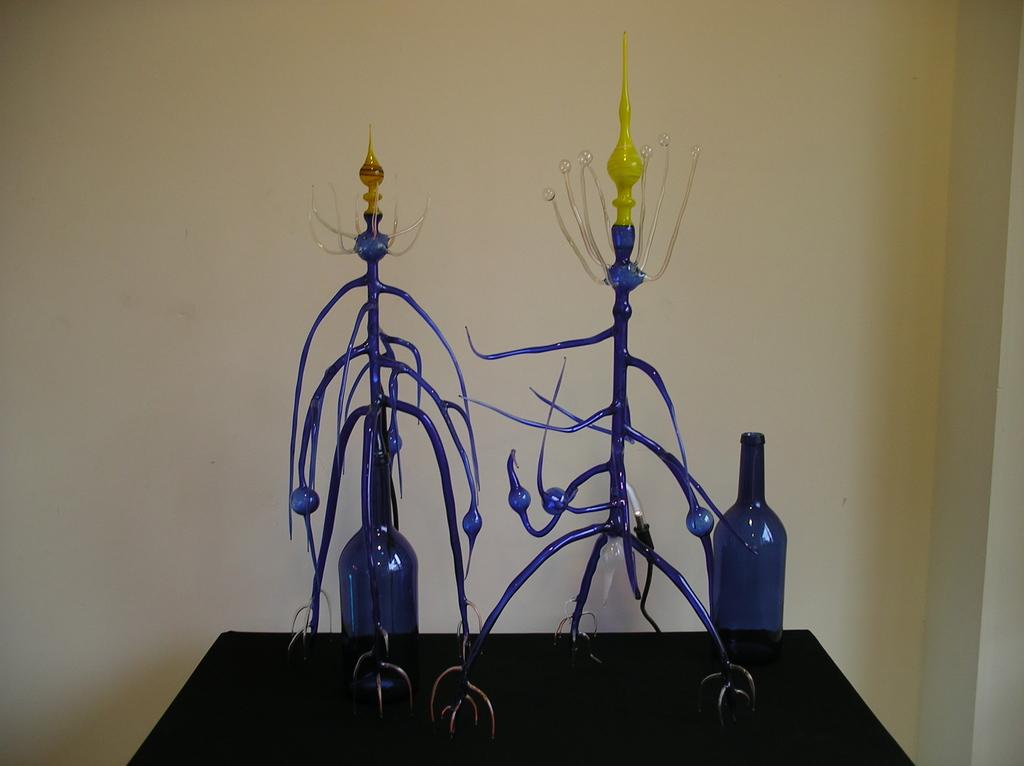What is the main object in the image? There is a table in the image. What is placed on the table? There are 2 glass bottles on the table. What can be seen in the background of the image? There is a wall visible in the background of the image. What color is the sweater worn by the friends in the image? There are no friends or sweaters present in the image; it only features a table with 2 glass bottles and a wall in the background. 